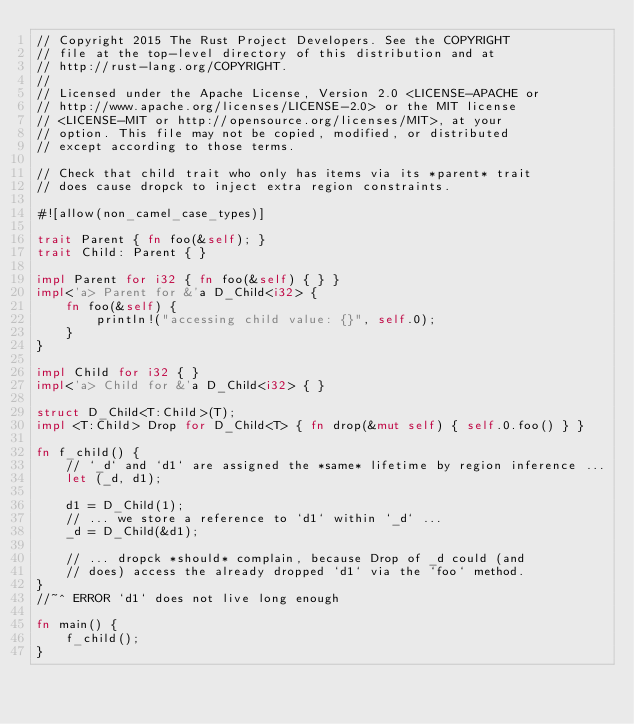<code> <loc_0><loc_0><loc_500><loc_500><_Rust_>// Copyright 2015 The Rust Project Developers. See the COPYRIGHT
// file at the top-level directory of this distribution and at
// http://rust-lang.org/COPYRIGHT.
//
// Licensed under the Apache License, Version 2.0 <LICENSE-APACHE or
// http://www.apache.org/licenses/LICENSE-2.0> or the MIT license
// <LICENSE-MIT or http://opensource.org/licenses/MIT>, at your
// option. This file may not be copied, modified, or distributed
// except according to those terms.

// Check that child trait who only has items via its *parent* trait
// does cause dropck to inject extra region constraints.

#![allow(non_camel_case_types)]

trait Parent { fn foo(&self); }
trait Child: Parent { }

impl Parent for i32 { fn foo(&self) { } }
impl<'a> Parent for &'a D_Child<i32> {
    fn foo(&self) {
        println!("accessing child value: {}", self.0);
    }
}

impl Child for i32 { }
impl<'a> Child for &'a D_Child<i32> { }

struct D_Child<T:Child>(T);
impl <T:Child> Drop for D_Child<T> { fn drop(&mut self) { self.0.foo() } }

fn f_child() {
    // `_d` and `d1` are assigned the *same* lifetime by region inference ...
    let (_d, d1);

    d1 = D_Child(1);
    // ... we store a reference to `d1` within `_d` ...
    _d = D_Child(&d1);

    // ... dropck *should* complain, because Drop of _d could (and
    // does) access the already dropped `d1` via the `foo` method.
}
//~^ ERROR `d1` does not live long enough

fn main() {
    f_child();
}
</code> 